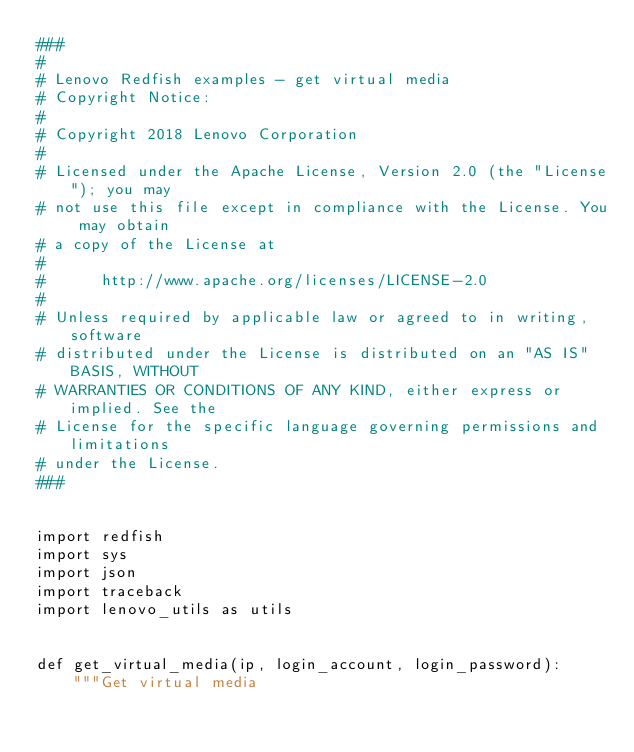<code> <loc_0><loc_0><loc_500><loc_500><_Python_>###
#
# Lenovo Redfish examples - get virtual media
# Copyright Notice:
#
# Copyright 2018 Lenovo Corporation
#
# Licensed under the Apache License, Version 2.0 (the "License"); you may
# not use this file except in compliance with the License. You may obtain
# a copy of the License at
#
#      http://www.apache.org/licenses/LICENSE-2.0
#
# Unless required by applicable law or agreed to in writing, software
# distributed under the License is distributed on an "AS IS" BASIS, WITHOUT
# WARRANTIES OR CONDITIONS OF ANY KIND, either express or implied. See the
# License for the specific language governing permissions and limitations
# under the License.
###


import redfish
import sys
import json
import traceback
import lenovo_utils as utils


def get_virtual_media(ip, login_account, login_password):
    """Get virtual media</code> 